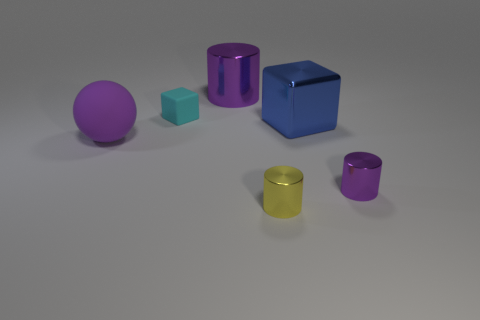Are there more shiny cylinders that are left of the large rubber sphere than tiny yellow cylinders?
Your answer should be compact. No. Does the small rubber object have the same shape as the large purple object that is behind the big rubber ball?
Provide a short and direct response. No. Are any brown rubber cylinders visible?
Your response must be concise. No. How many big things are either shiny cylinders or brown rubber cylinders?
Your answer should be very brief. 1. Is the number of cyan matte cubes behind the small block greater than the number of purple rubber balls that are in front of the big purple ball?
Keep it short and to the point. No. Do the cyan cube and the purple thing that is to the right of the big blue thing have the same material?
Ensure brevity in your answer.  No. What is the color of the small matte block?
Offer a terse response. Cyan. The big thing in front of the large blue shiny block has what shape?
Make the answer very short. Sphere. How many cyan things are either cylinders or matte spheres?
Provide a short and direct response. 0. There is a large thing that is the same material as the small cube; what is its color?
Provide a short and direct response. Purple. 